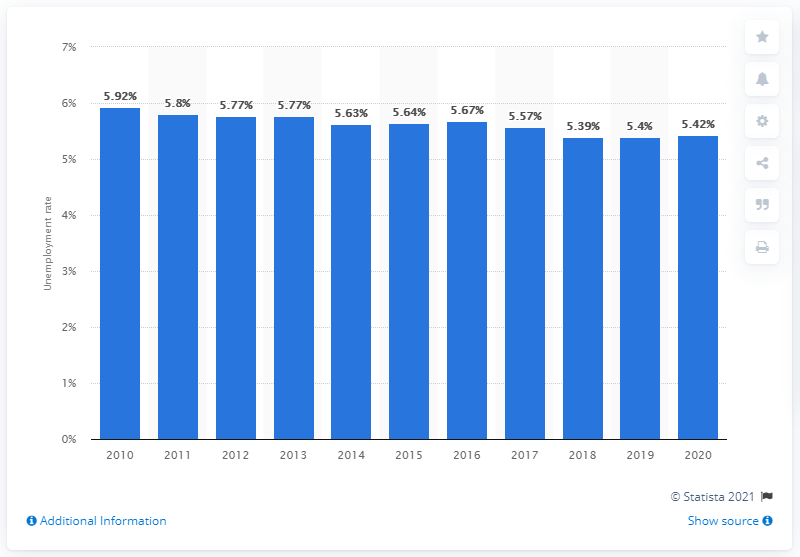Highlight a few significant elements in this photo. As of 2020, the global unemployment rate was 5.42%. 